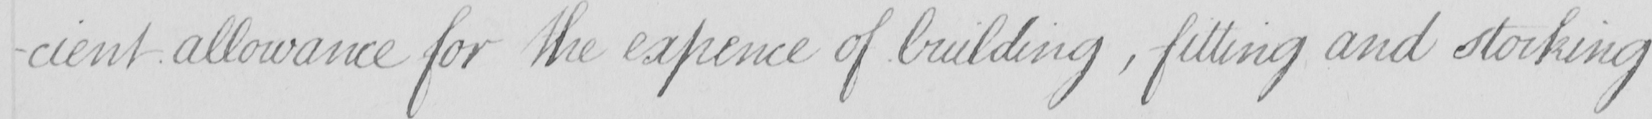Transcribe the text shown in this historical manuscript line. -cient allowance for the expence of building  , fitting and stocking 